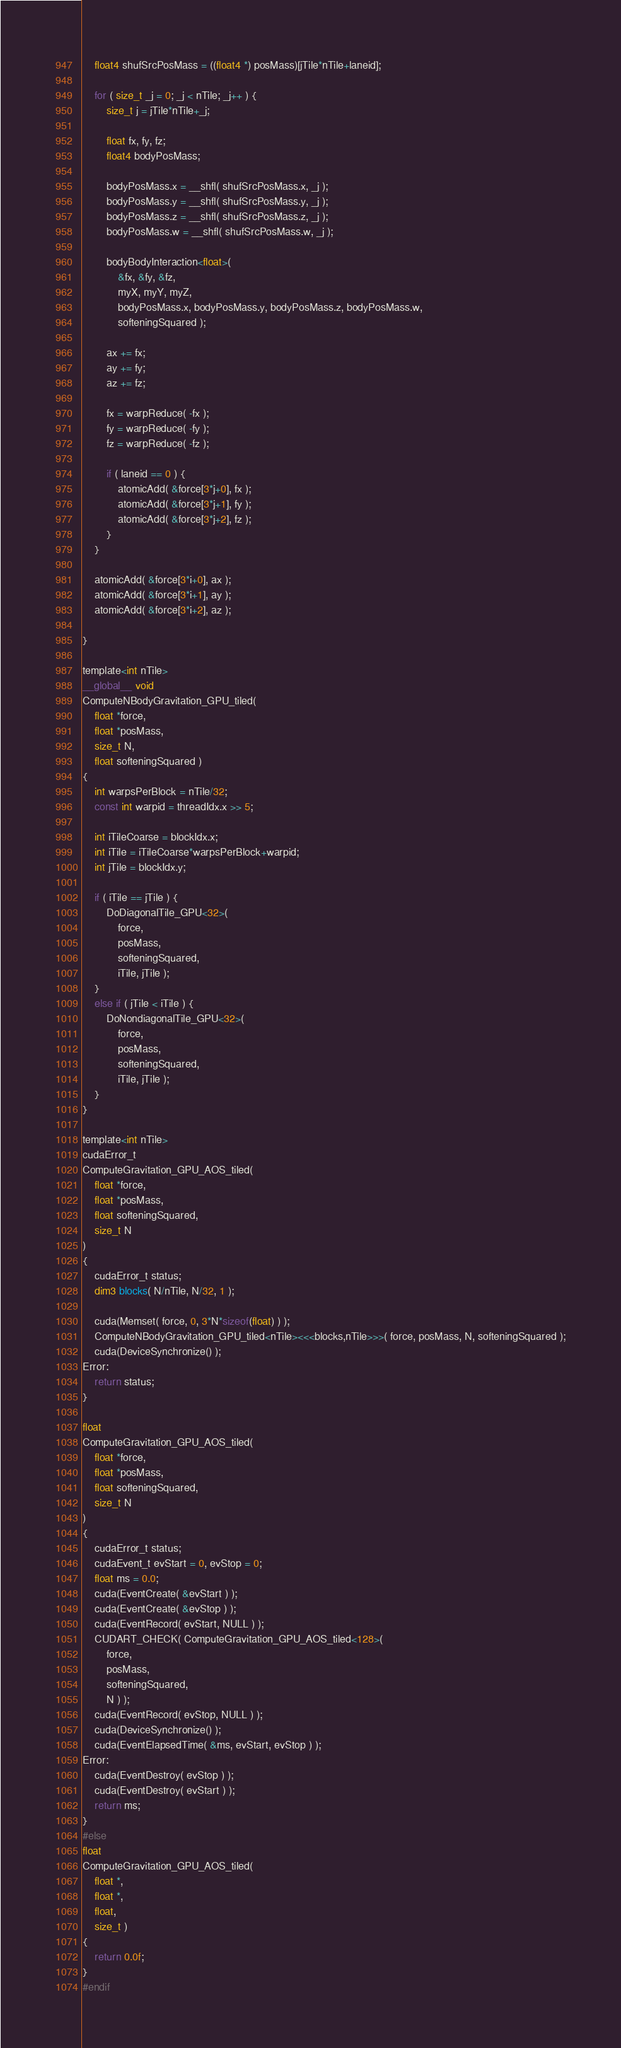Convert code to text. <code><loc_0><loc_0><loc_500><loc_500><_Cuda_>    float4 shufSrcPosMass = ((float4 *) posMass)[jTile*nTile+laneid];

    for ( size_t _j = 0; _j < nTile; _j++ ) {
        size_t j = jTile*nTile+_j;

        float fx, fy, fz;
        float4 bodyPosMass;

        bodyPosMass.x = __shfl( shufSrcPosMass.x, _j );
        bodyPosMass.y = __shfl( shufSrcPosMass.y, _j );
        bodyPosMass.z = __shfl( shufSrcPosMass.z, _j );
        bodyPosMass.w = __shfl( shufSrcPosMass.w, _j );

        bodyBodyInteraction<float>(
            &fx, &fy, &fz,
            myX, myY, myZ,
            bodyPosMass.x, bodyPosMass.y, bodyPosMass.z, bodyPosMass.w,
            softeningSquared );

        ax += fx;
        ay += fy;
        az += fz;

        fx = warpReduce( -fx );
        fy = warpReduce( -fy );
        fz = warpReduce( -fz );

        if ( laneid == 0 ) {
            atomicAdd( &force[3*j+0], fx );
            atomicAdd( &force[3*j+1], fy );
            atomicAdd( &force[3*j+2], fz );
        }
    }

    atomicAdd( &force[3*i+0], ax );
    atomicAdd( &force[3*i+1], ay );
    atomicAdd( &force[3*i+2], az );

}

template<int nTile>
__global__ void
ComputeNBodyGravitation_GPU_tiled( 
    float *force, 
    float *posMass, 
    size_t N, 
    float softeningSquared )
{
    int warpsPerBlock = nTile/32;
    const int warpid = threadIdx.x >> 5;

    int iTileCoarse = blockIdx.x;
    int iTile = iTileCoarse*warpsPerBlock+warpid;
    int jTile = blockIdx.y;

    if ( iTile == jTile ) {
        DoDiagonalTile_GPU<32>( 
            force, 
            posMass, 
            softeningSquared, 
            iTile, jTile );
    }
    else if ( jTile < iTile ) {
        DoNondiagonalTile_GPU<32>( 
            force, 
            posMass, 
            softeningSquared, 
            iTile, jTile );
    }
}

template<int nTile>
cudaError_t
ComputeGravitation_GPU_AOS_tiled(
    float *force, 
    float *posMass,
    float softeningSquared,
    size_t N
)
{
    cudaError_t status;
    dim3 blocks( N/nTile, N/32, 1 );

    cuda(Memset( force, 0, 3*N*sizeof(float) ) );
    ComputeNBodyGravitation_GPU_tiled<nTile><<<blocks,nTile>>>( force, posMass, N, softeningSquared );
    cuda(DeviceSynchronize() );
Error:
    return status;
}

float
ComputeGravitation_GPU_AOS_tiled(
    float *force, 
    float *posMass,
    float softeningSquared,
    size_t N
)
{
    cudaError_t status;
    cudaEvent_t evStart = 0, evStop = 0;
    float ms = 0.0;
    cuda(EventCreate( &evStart ) );
    cuda(EventCreate( &evStop ) );
    cuda(EventRecord( evStart, NULL ) );
    CUDART_CHECK( ComputeGravitation_GPU_AOS_tiled<128>(
        force, 
        posMass,
        softeningSquared,
        N ) );
    cuda(EventRecord( evStop, NULL ) );
    cuda(DeviceSynchronize() );
    cuda(EventElapsedTime( &ms, evStart, evStop ) );
Error:
    cuda(EventDestroy( evStop ) );
    cuda(EventDestroy( evStart ) );
    return ms;
}
#else
float
ComputeGravitation_GPU_AOS_tiled(
    float *,
    float *,
    float,
    size_t )
{
    return 0.0f;
}
#endif

</code> 